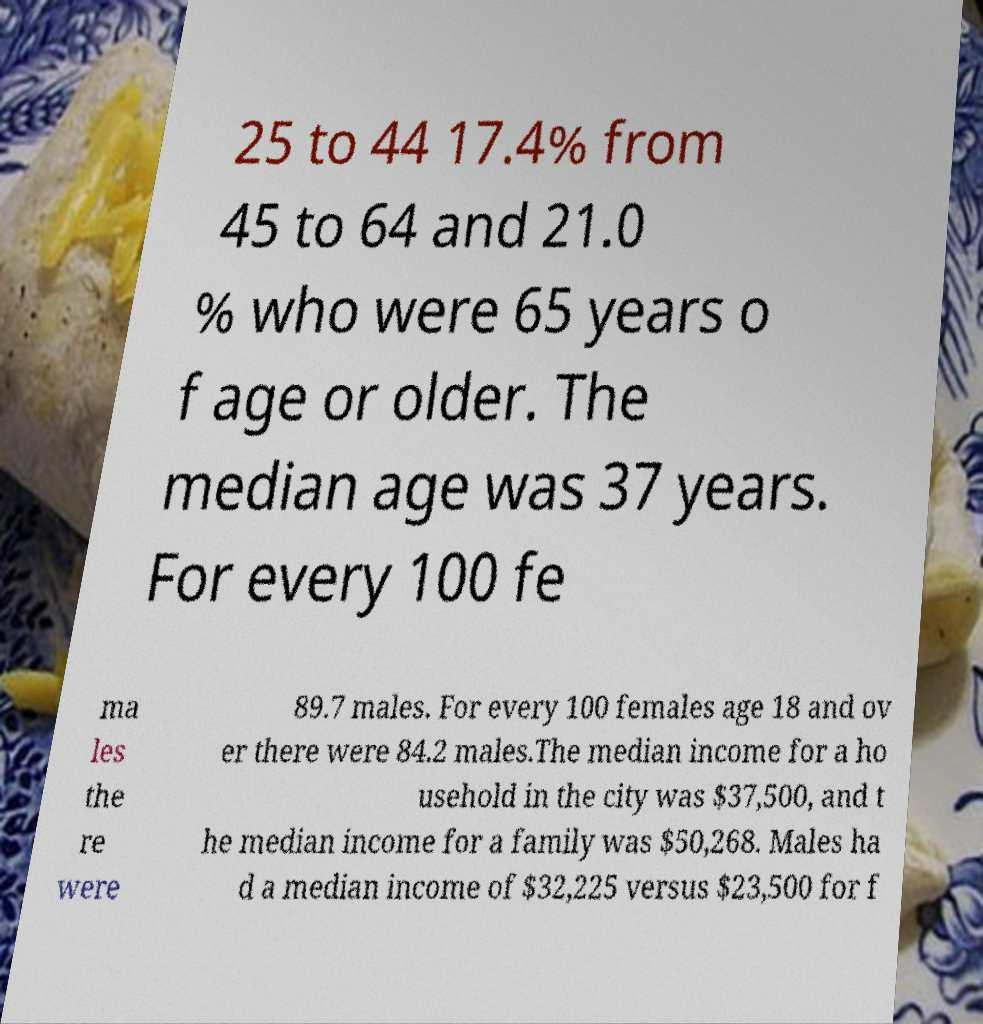Could you extract and type out the text from this image? 25 to 44 17.4% from 45 to 64 and 21.0 % who were 65 years o f age or older. The median age was 37 years. For every 100 fe ma les the re were 89.7 males. For every 100 females age 18 and ov er there were 84.2 males.The median income for a ho usehold in the city was $37,500, and t he median income for a family was $50,268. Males ha d a median income of $32,225 versus $23,500 for f 